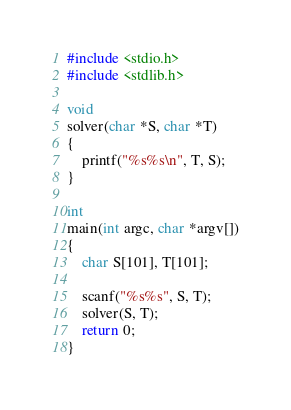<code> <loc_0><loc_0><loc_500><loc_500><_C_>#include <stdio.h>
#include <stdlib.h>

void
solver(char *S, char *T)
{
    printf("%s%s\n", T, S);
}

int
main(int argc, char *argv[])
{
    char S[101], T[101];

    scanf("%s%s", S, T);
    solver(S, T);
    return 0;
}</code> 